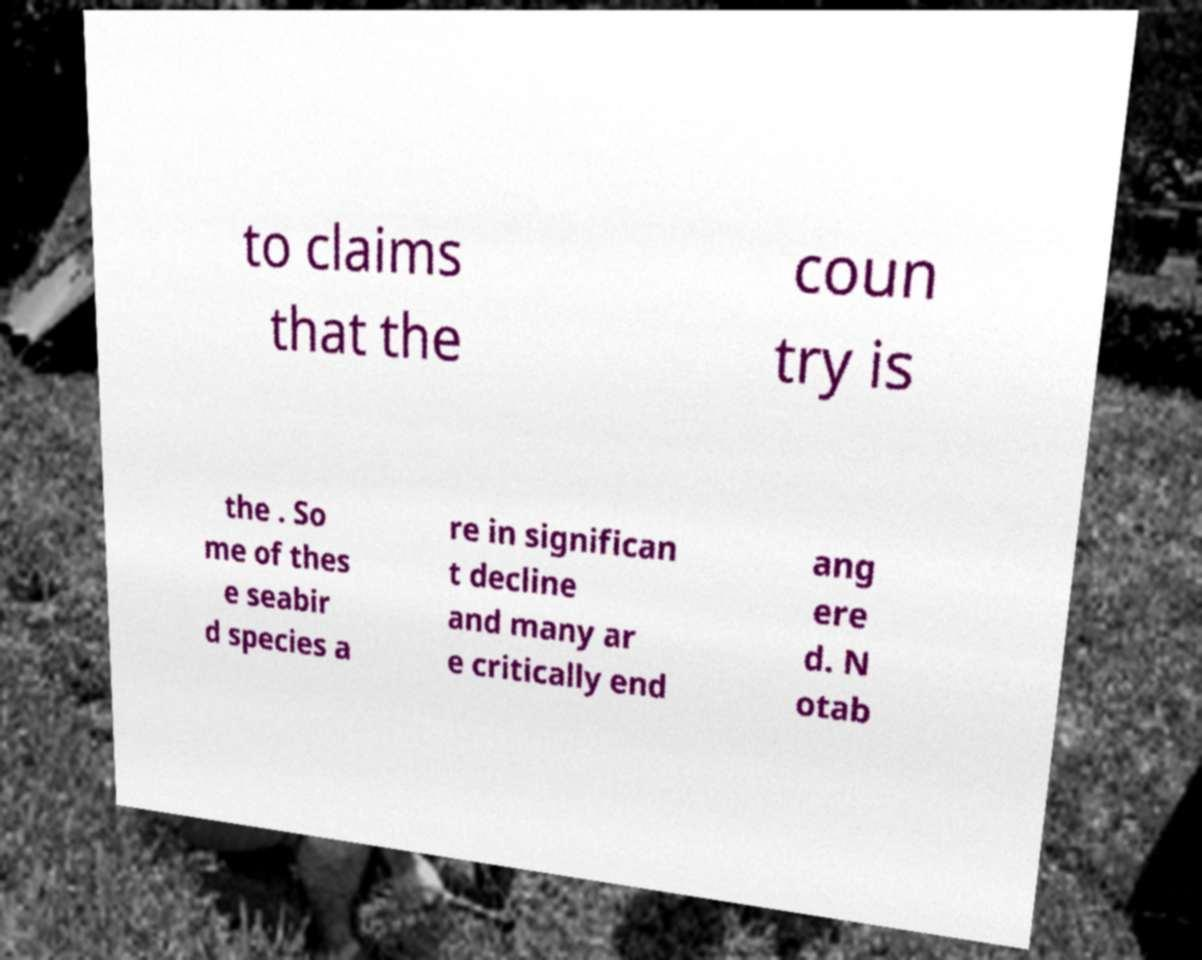Could you extract and type out the text from this image? to claims that the coun try is the . So me of thes e seabir d species a re in significan t decline and many ar e critically end ang ere d. N otab 